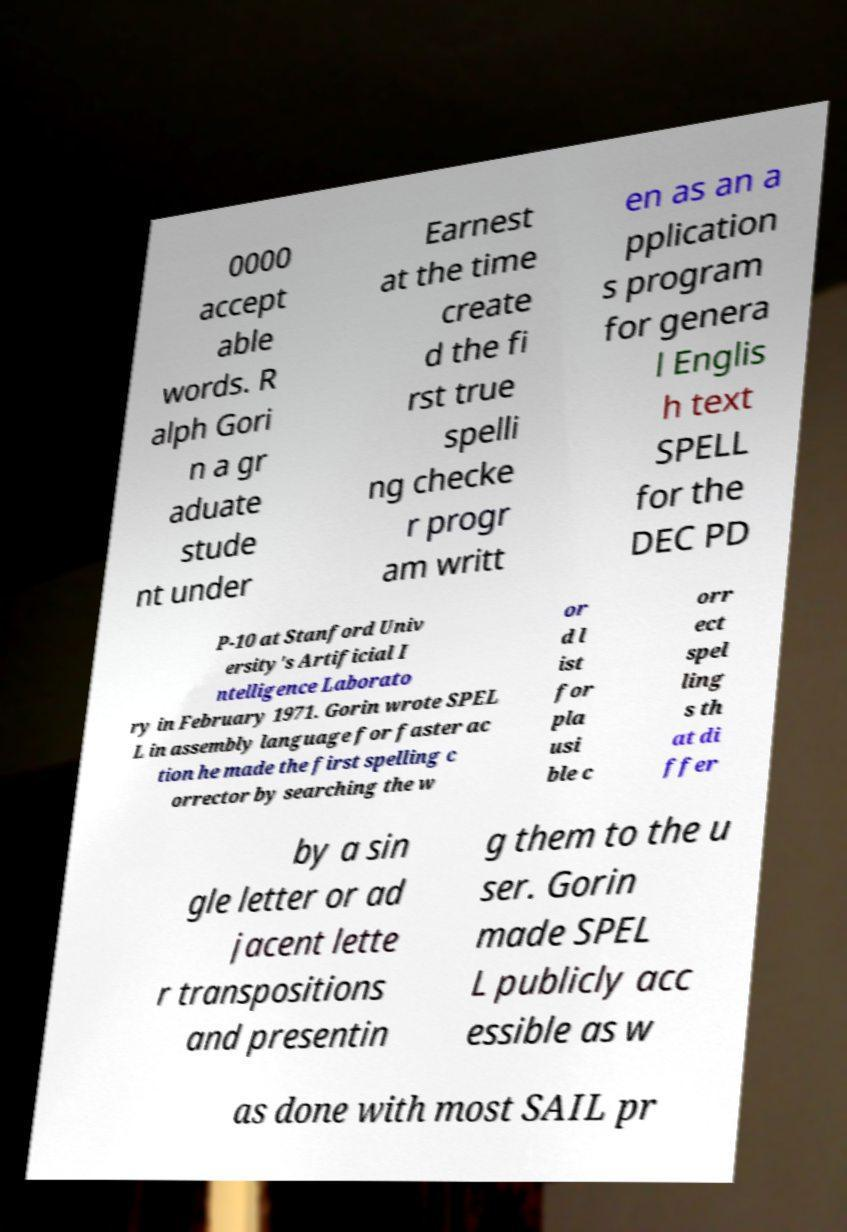Please identify and transcribe the text found in this image. 0000 accept able words. R alph Gori n a gr aduate stude nt under Earnest at the time create d the fi rst true spelli ng checke r progr am writt en as an a pplication s program for genera l Englis h text SPELL for the DEC PD P-10 at Stanford Univ ersity's Artificial I ntelligence Laborato ry in February 1971. Gorin wrote SPEL L in assembly language for faster ac tion he made the first spelling c orrector by searching the w or d l ist for pla usi ble c orr ect spel ling s th at di ffer by a sin gle letter or ad jacent lette r transpositions and presentin g them to the u ser. Gorin made SPEL L publicly acc essible as w as done with most SAIL pr 